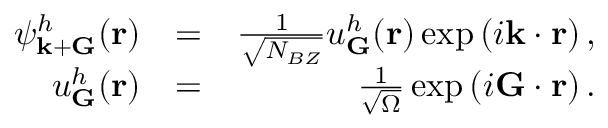Convert formula to latex. <formula><loc_0><loc_0><loc_500><loc_500>\begin{array} { r l r } { \psi _ { { k } + { G } } ^ { h } ( { r } ) } & { = } & { \frac { 1 } { \sqrt { N _ { B Z } } } u _ { G } ^ { h } ( { r } ) \exp \left ( i { k } \cdot { r } \right ) , } \\ { u _ { G } ^ { h } ( { r } ) } & { = } & { \frac { 1 } { \sqrt { \Omega } } \exp \left ( i { G } \cdot { r } \right ) . } \end{array}</formula> 